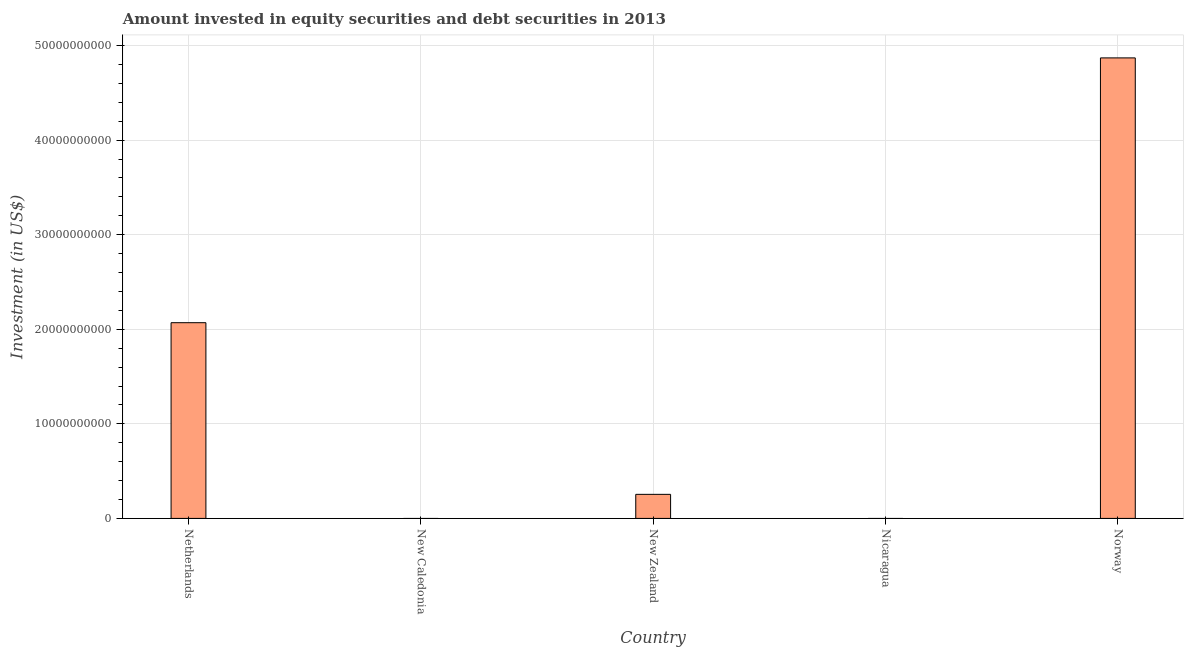Does the graph contain grids?
Provide a short and direct response. Yes. What is the title of the graph?
Your answer should be compact. Amount invested in equity securities and debt securities in 2013. What is the label or title of the X-axis?
Offer a very short reply. Country. What is the label or title of the Y-axis?
Your response must be concise. Investment (in US$). What is the portfolio investment in New Caledonia?
Offer a very short reply. 0. Across all countries, what is the maximum portfolio investment?
Offer a terse response. 4.87e+1. What is the sum of the portfolio investment?
Provide a succinct answer. 7.19e+1. What is the difference between the portfolio investment in New Zealand and Norway?
Provide a succinct answer. -4.62e+1. What is the average portfolio investment per country?
Keep it short and to the point. 1.44e+1. What is the median portfolio investment?
Give a very brief answer. 2.54e+09. In how many countries, is the portfolio investment greater than 46000000000 US$?
Your response must be concise. 1. Is the portfolio investment in Netherlands less than that in New Zealand?
Provide a short and direct response. No. Is the difference between the portfolio investment in Netherlands and New Zealand greater than the difference between any two countries?
Offer a very short reply. No. What is the difference between the highest and the second highest portfolio investment?
Provide a succinct answer. 2.80e+1. What is the difference between the highest and the lowest portfolio investment?
Make the answer very short. 4.87e+1. What is the difference between two consecutive major ticks on the Y-axis?
Provide a succinct answer. 1.00e+1. What is the Investment (in US$) of Netherlands?
Offer a very short reply. 2.07e+1. What is the Investment (in US$) of New Zealand?
Ensure brevity in your answer.  2.54e+09. What is the Investment (in US$) of Nicaragua?
Provide a short and direct response. 0. What is the Investment (in US$) of Norway?
Your answer should be very brief. 4.87e+1. What is the difference between the Investment (in US$) in Netherlands and New Zealand?
Ensure brevity in your answer.  1.82e+1. What is the difference between the Investment (in US$) in Netherlands and Norway?
Keep it short and to the point. -2.80e+1. What is the difference between the Investment (in US$) in New Zealand and Norway?
Offer a very short reply. -4.62e+1. What is the ratio of the Investment (in US$) in Netherlands to that in New Zealand?
Provide a succinct answer. 8.13. What is the ratio of the Investment (in US$) in Netherlands to that in Norway?
Ensure brevity in your answer.  0.42. What is the ratio of the Investment (in US$) in New Zealand to that in Norway?
Your response must be concise. 0.05. 